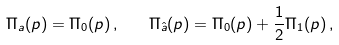<formula> <loc_0><loc_0><loc_500><loc_500>\Pi _ { a } ( p ) = \Pi _ { 0 } ( p ) \, , \quad \Pi _ { \hat { a } } ( p ) = \Pi _ { 0 } ( p ) + \frac { 1 } { 2 } \Pi _ { 1 } ( p ) \, ,</formula> 